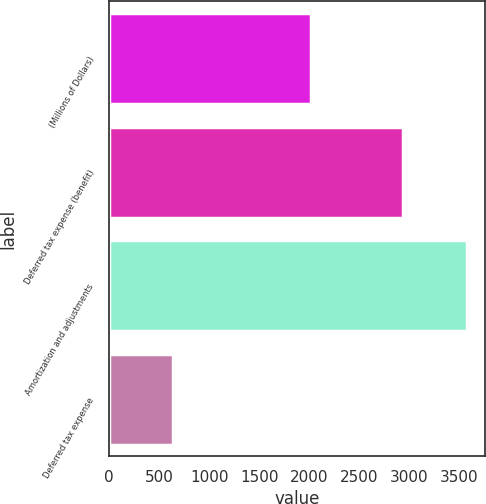Convert chart to OTSL. <chart><loc_0><loc_0><loc_500><loc_500><bar_chart><fcel>(Millions of Dollars)<fcel>Deferred tax expense (benefit)<fcel>Amortization and adjustments<fcel>Deferred tax expense<nl><fcel>2017<fcel>2939<fcel>3583<fcel>640<nl></chart> 